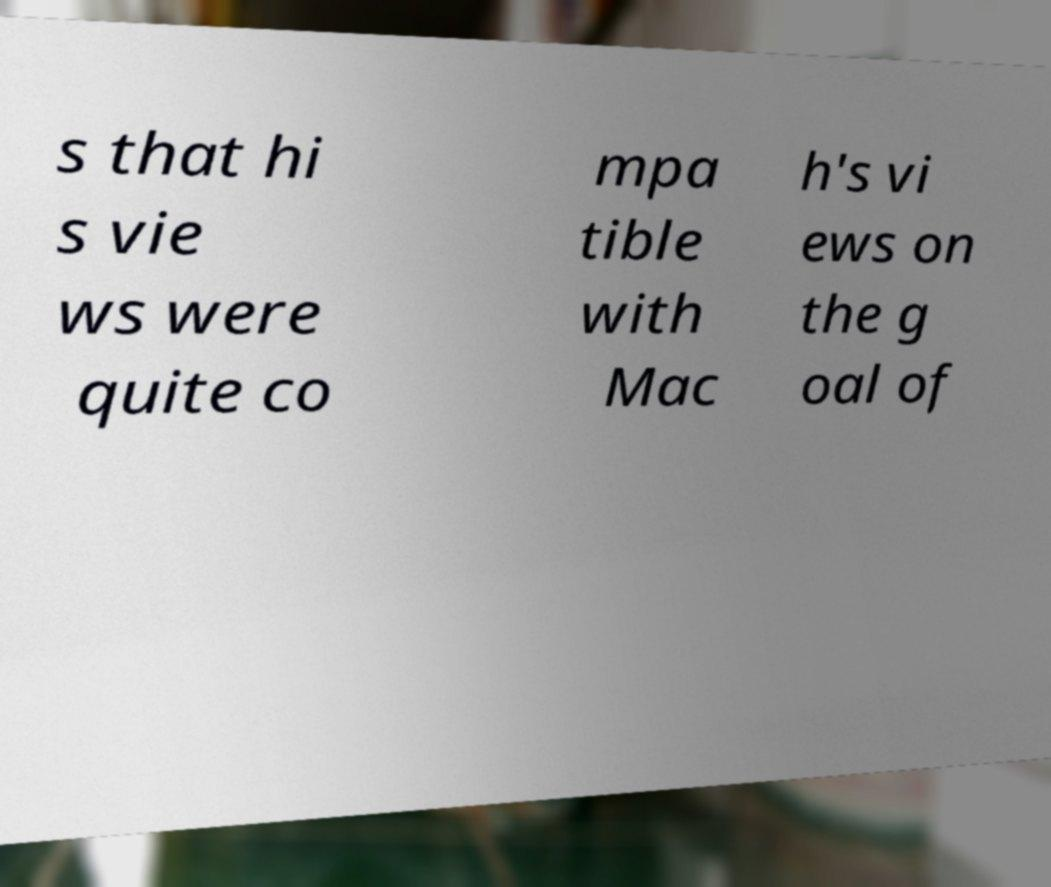Please read and relay the text visible in this image. What does it say? s that hi s vie ws were quite co mpa tible with Mac h's vi ews on the g oal of 